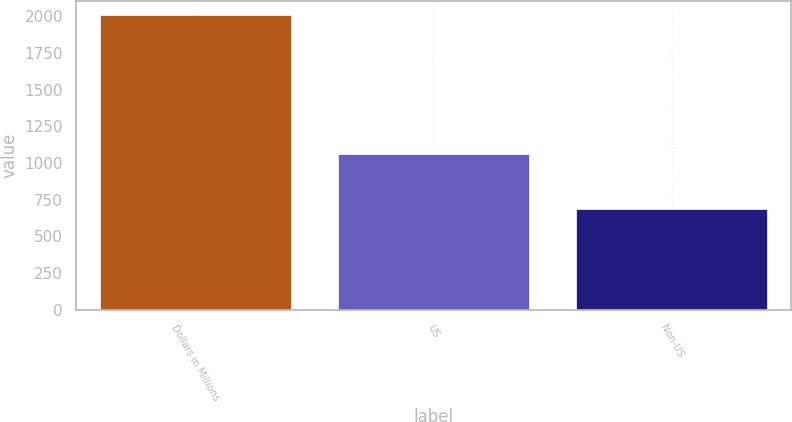<chart> <loc_0><loc_0><loc_500><loc_500><bar_chart><fcel>Dollars in Millions<fcel>US<fcel>Non-US<nl><fcel>2005<fcel>1058<fcel>686<nl></chart> 